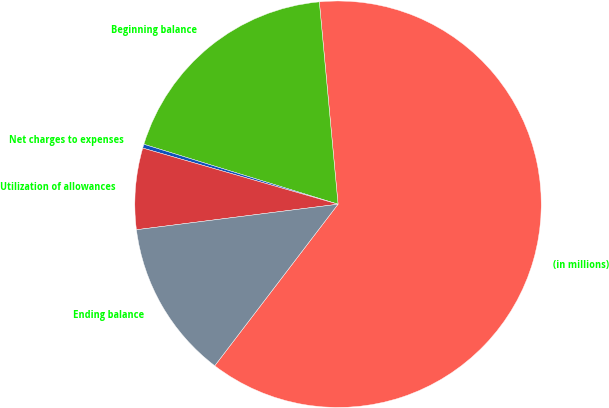Convert chart. <chart><loc_0><loc_0><loc_500><loc_500><pie_chart><fcel>(in millions)<fcel>Beginning balance<fcel>Net charges to expenses<fcel>Utilization of allowances<fcel>Ending balance<nl><fcel>61.85%<fcel>18.77%<fcel>0.31%<fcel>6.46%<fcel>12.62%<nl></chart> 